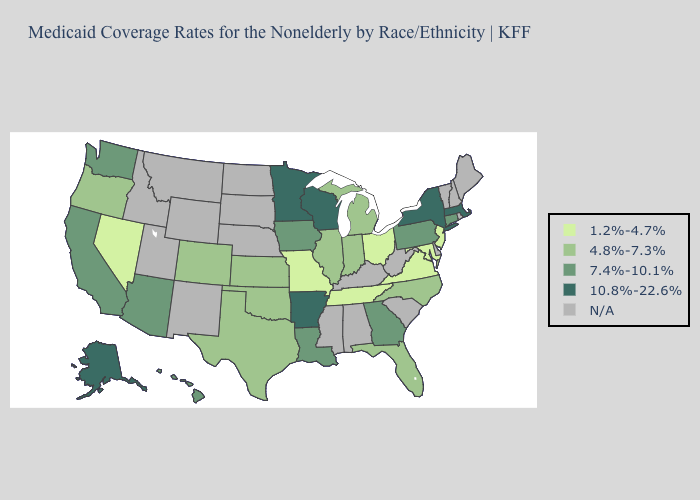What is the lowest value in the USA?
Be succinct. 1.2%-4.7%. Does Connecticut have the lowest value in the USA?
Short answer required. No. What is the lowest value in the USA?
Keep it brief. 1.2%-4.7%. Does the first symbol in the legend represent the smallest category?
Concise answer only. Yes. Name the states that have a value in the range 10.8%-22.6%?
Short answer required. Alaska, Arkansas, Massachusetts, Minnesota, New York, Wisconsin. What is the lowest value in states that border Missouri?
Quick response, please. 1.2%-4.7%. What is the value of Oklahoma?
Short answer required. 4.8%-7.3%. Does Alaska have the highest value in the USA?
Be succinct. Yes. What is the lowest value in the South?
Quick response, please. 1.2%-4.7%. Name the states that have a value in the range 4.8%-7.3%?
Quick response, please. Colorado, Florida, Illinois, Indiana, Kansas, Michigan, North Carolina, Oklahoma, Oregon, Texas. What is the lowest value in the USA?
Give a very brief answer. 1.2%-4.7%. What is the highest value in states that border Maryland?
Concise answer only. 7.4%-10.1%. Name the states that have a value in the range 1.2%-4.7%?
Short answer required. Maryland, Missouri, Nevada, New Jersey, Ohio, Tennessee, Virginia. What is the value of Louisiana?
Give a very brief answer. 7.4%-10.1%. Which states have the lowest value in the USA?
Quick response, please. Maryland, Missouri, Nevada, New Jersey, Ohio, Tennessee, Virginia. 